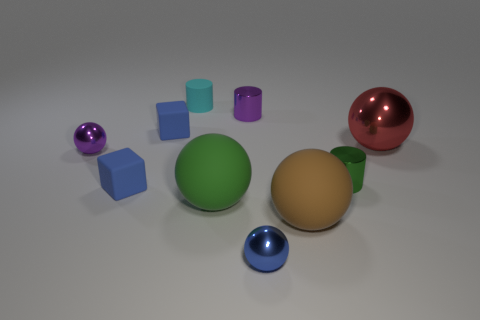Subtract all green cylinders. How many cylinders are left? 2 Subtract 5 balls. How many balls are left? 0 Subtract all purple cylinders. How many cylinders are left? 2 Add 4 balls. How many balls are left? 9 Add 2 shiny cylinders. How many shiny cylinders exist? 4 Subtract 1 purple cylinders. How many objects are left? 9 Subtract all cylinders. How many objects are left? 7 Subtract all yellow cylinders. Subtract all brown spheres. How many cylinders are left? 3 Subtract all blue blocks. How many yellow balls are left? 0 Subtract all big metallic objects. Subtract all small metallic cylinders. How many objects are left? 7 